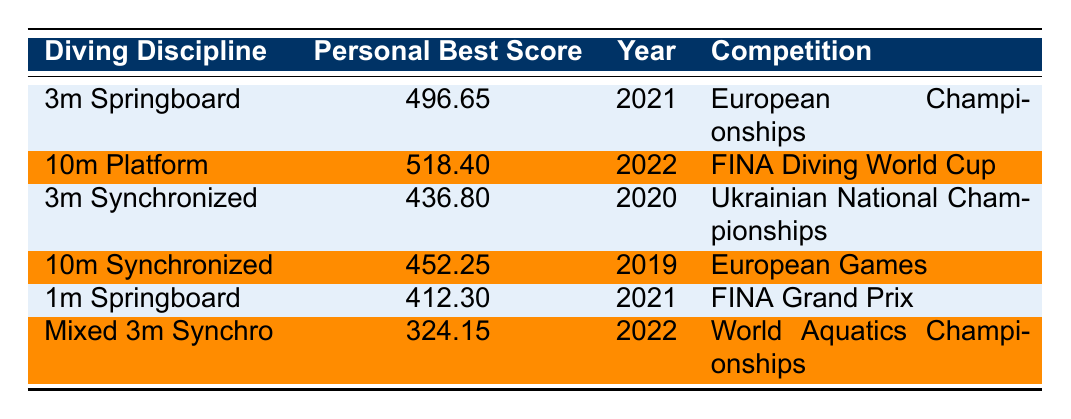What was Kirill Boliukh's personal best score in the 10m Platform event? The table lists the personal best score for the 10m Platform event as 518.40.
Answer: 518.40 In which year did Kirill Boliukh achieve his personal best score for the 1m Springboard? According to the table, the personal best score for the 1m Springboard was achieved in 2021.
Answer: 2021 What is the difference between Kirill Boliukh's personal best scores in the 3m Synchronized and Mixed 3m Synchro events? The personal best score for the 3m Synchronized is 436.80 and for Mixed 3m Synchro is 324.15. The difference is calculated as 436.80 - 324.15 = 112.65.
Answer: 112.65 Did Kirill Boliukh compete in the European Championships? Yes, the table shows that Kirill competed in the European Championships in 2021 for the 3m Springboard event.
Answer: Yes What was the highest personal best score recorded by Kirill Boliukh, and in which event did it occur? The highest score is 518.40, which was recorded in the 10m Platform event at the FINA Diving World Cup in 2022.
Answer: 518.40, 10m Platform What is the average personal best score for the 3m Springboard and 1m Springboard? The personal best scores for the 3m Springboard and 1m Springboard are 496.65 and 412.30, respectively. To find the average, we calculate (496.65 + 412.30) / 2 = 454.475.
Answer: 454.475 How many competitions did Kirill Boliukh participate in that took place in 2022? The table indicates that there were two entries for the year 2022: 10m Platform at the FINA Diving World Cup and Mixed 3m Synchro at the World Aquatics Championships. Therefore, he participated in 2 competitions in that year.
Answer: 2 Was Kirill's personal best score for the 10m Synchronized event higher than for the 3m Synchronized event? The score for 10m Synchronized is 452.25 while 3m Synchronized is 436.80. Since 452.25 > 436.80, the answer is yes.
Answer: Yes 